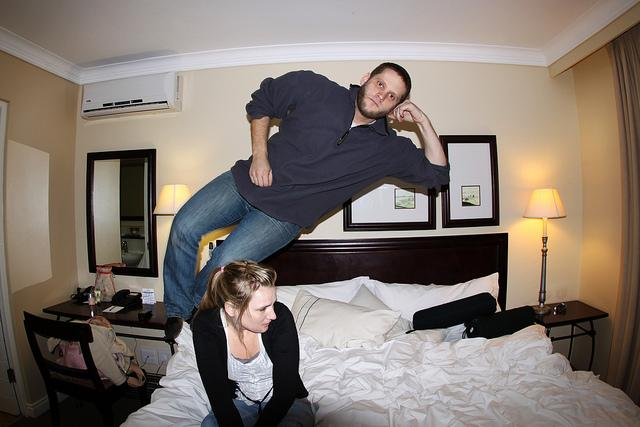Why does the man stand so strangely here? posing 